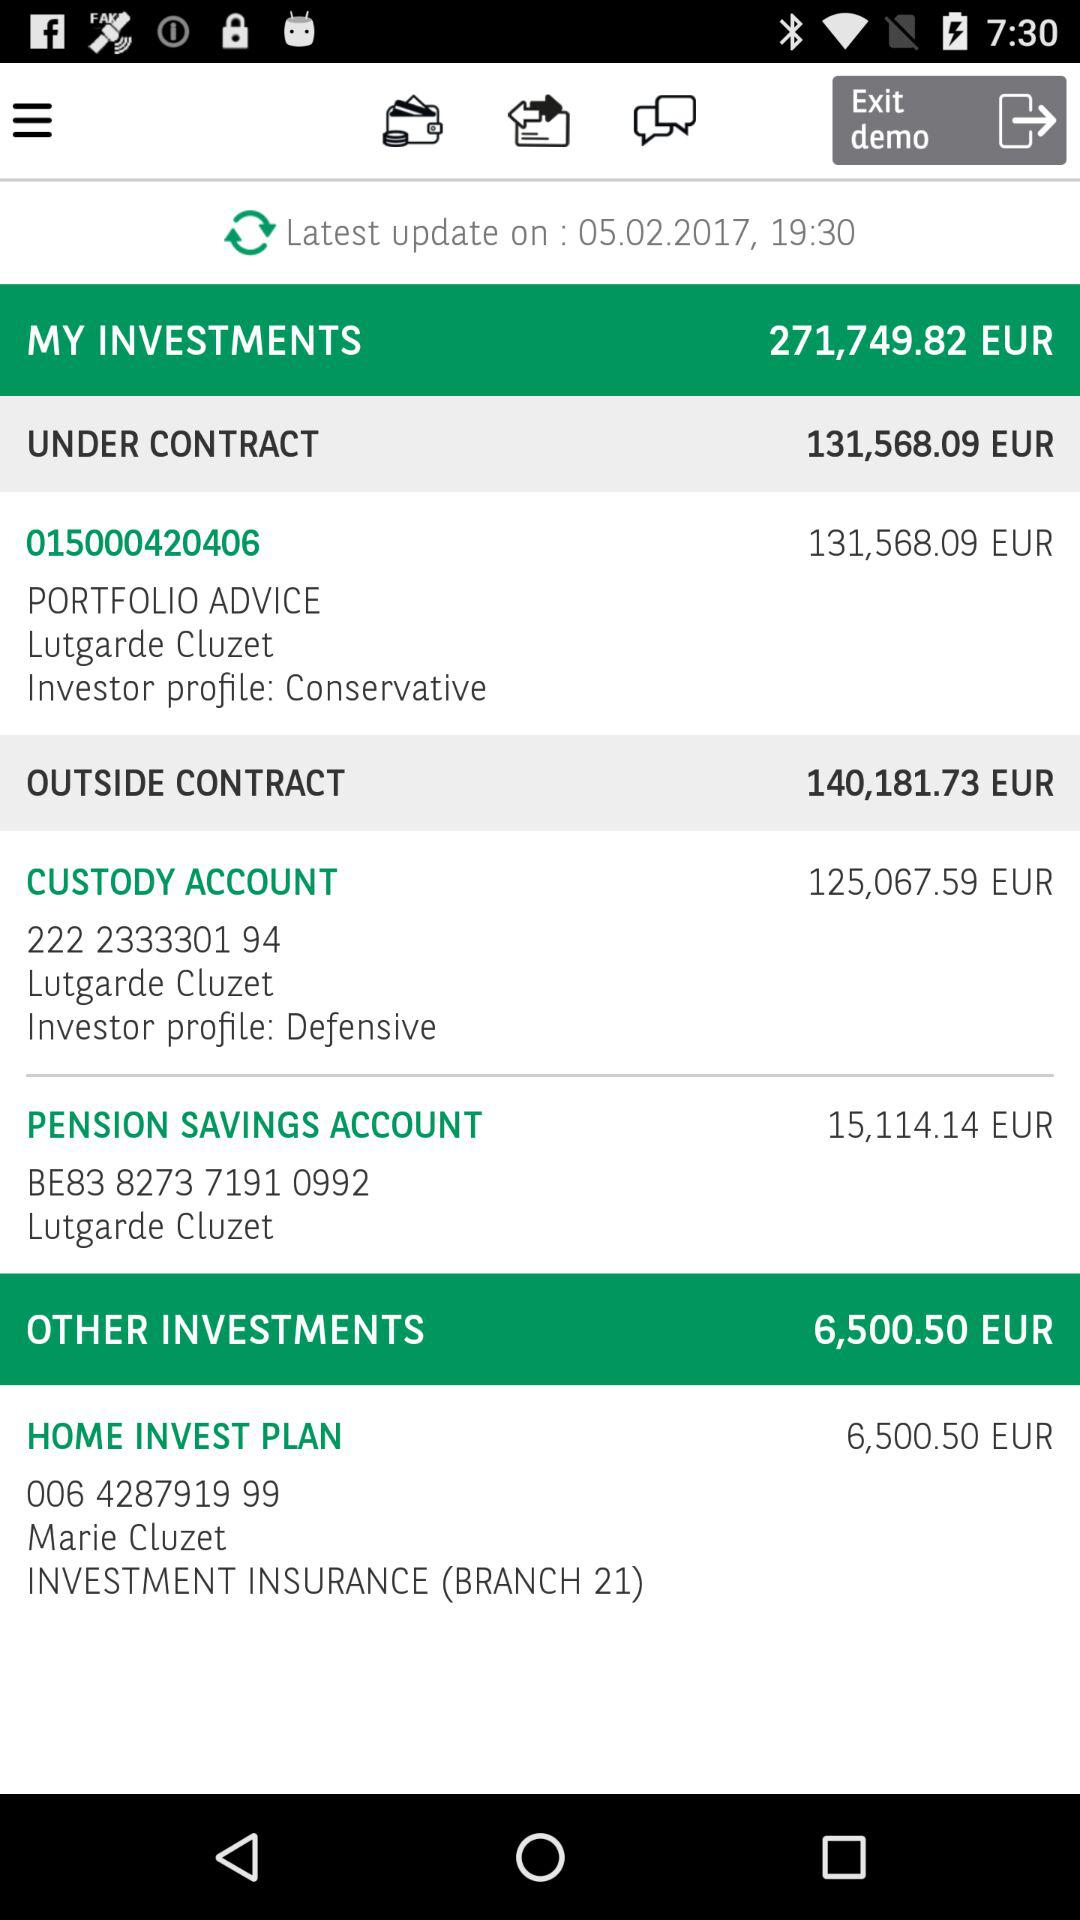How much are the other investments? The other investments are 6,500.50 EUR. 